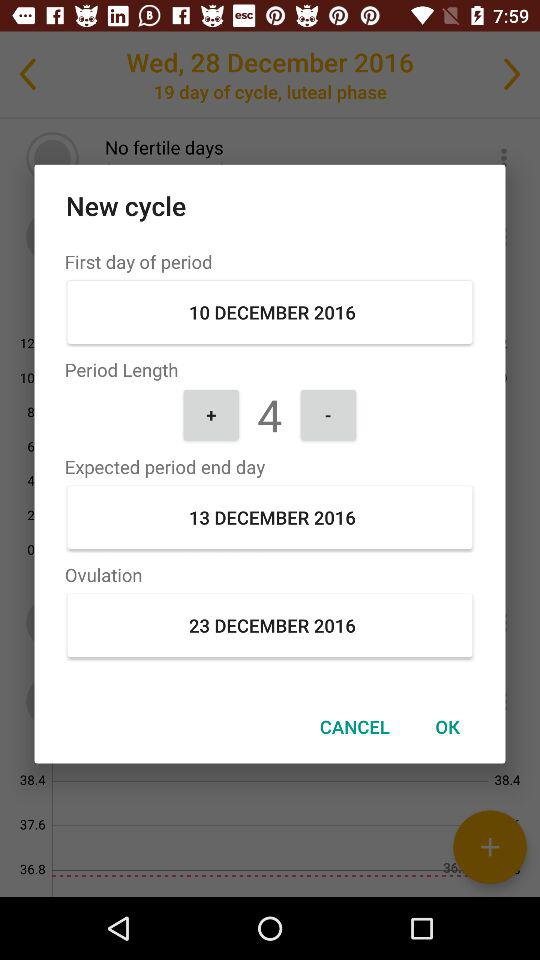How many days after the first day of period is ovulation?
Answer the question using a single word or phrase. 13 